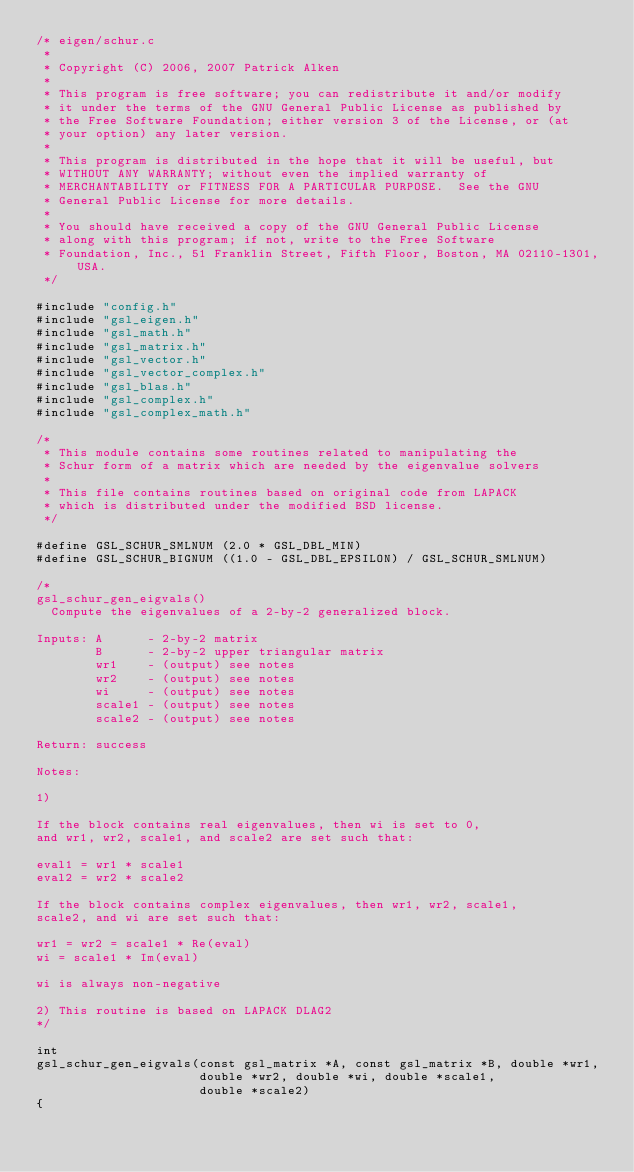<code> <loc_0><loc_0><loc_500><loc_500><_C_>/* eigen/schur.c
 * 
 * Copyright (C) 2006, 2007 Patrick Alken
 * 
 * This program is free software; you can redistribute it and/or modify
 * it under the terms of the GNU General Public License as published by
 * the Free Software Foundation; either version 3 of the License, or (at
 * your option) any later version.
 * 
 * This program is distributed in the hope that it will be useful, but
 * WITHOUT ANY WARRANTY; without even the implied warranty of
 * MERCHANTABILITY or FITNESS FOR A PARTICULAR PURPOSE.  See the GNU
 * General Public License for more details.
 * 
 * You should have received a copy of the GNU General Public License
 * along with this program; if not, write to the Free Software
 * Foundation, Inc., 51 Franklin Street, Fifth Floor, Boston, MA 02110-1301, USA.
 */

#include "config.h"
#include "gsl_eigen.h"
#include "gsl_math.h"
#include "gsl_matrix.h"
#include "gsl_vector.h"
#include "gsl_vector_complex.h"
#include "gsl_blas.h"
#include "gsl_complex.h"
#include "gsl_complex_math.h"

/*
 * This module contains some routines related to manipulating the
 * Schur form of a matrix which are needed by the eigenvalue solvers
 *
 * This file contains routines based on original code from LAPACK
 * which is distributed under the modified BSD license.
 */

#define GSL_SCHUR_SMLNUM (2.0 * GSL_DBL_MIN)
#define GSL_SCHUR_BIGNUM ((1.0 - GSL_DBL_EPSILON) / GSL_SCHUR_SMLNUM)

/*
gsl_schur_gen_eigvals()
  Compute the eigenvalues of a 2-by-2 generalized block.

Inputs: A      - 2-by-2 matrix
        B      - 2-by-2 upper triangular matrix
        wr1    - (output) see notes
        wr2    - (output) see notes
        wi     - (output) see notes
        scale1 - (output) see notes
        scale2 - (output) see notes

Return: success

Notes:

1)

If the block contains real eigenvalues, then wi is set to 0,
and wr1, wr2, scale1, and scale2 are set such that:

eval1 = wr1 * scale1
eval2 = wr2 * scale2

If the block contains complex eigenvalues, then wr1, wr2, scale1,
scale2, and wi are set such that:

wr1 = wr2 = scale1 * Re(eval)
wi = scale1 * Im(eval)

wi is always non-negative

2) This routine is based on LAPACK DLAG2
*/

int
gsl_schur_gen_eigvals(const gsl_matrix *A, const gsl_matrix *B, double *wr1,
                      double *wr2, double *wi, double *scale1,
                      double *scale2)
{</code> 